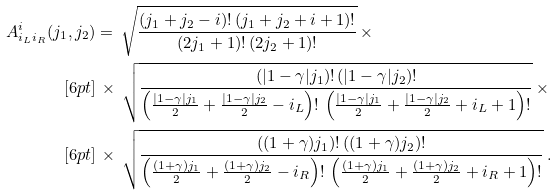<formula> <loc_0><loc_0><loc_500><loc_500>A ^ { i } _ { i _ { L } i _ { R } } ( j _ { 1 } , j _ { 2 } ) & = \, \sqrt { \frac { ( j _ { 1 } + j _ { 2 } - i ) ! \, ( j _ { 1 } + j _ { 2 } + i + 1 ) ! } { ( 2 j _ { 1 } + 1 ) ! \, ( 2 j _ { 2 } + 1 ) ! } } \, \times \\ [ 6 p t ] & \, \times \, \sqrt { \frac { ( | 1 - \gamma | j _ { 1 } ) ! \, ( | 1 - \gamma | j _ { 2 } ) ! } { \left ( \frac { | 1 - \gamma | j _ { 1 } } { 2 } + \frac { | 1 - \gamma | j _ { 2 } } { 2 } - i _ { L } \right ) ! \, \left ( \frac { | 1 - \gamma | j _ { 1 } } { 2 } + \frac { | 1 - \gamma | j _ { 2 } } { 2 } + i _ { L } + 1 \right ) ! } } \, \times \\ [ 6 p t ] & \, \times \, \sqrt { \frac { ( ( 1 + \gamma ) j _ { 1 } ) ! \, ( ( 1 + \gamma ) j _ { 2 } ) ! } { \left ( \frac { ( 1 + \gamma ) j _ { 1 } } { 2 } + \frac { ( 1 + \gamma ) j _ { 2 } } { 2 } - i _ { R } \right ) ! \, \left ( \frac { ( 1 + \gamma ) j _ { 1 } } { 2 } + \frac { ( 1 + \gamma ) j _ { 2 } } { 2 } + i _ { R } + 1 \right ) ! } } \, .</formula> 